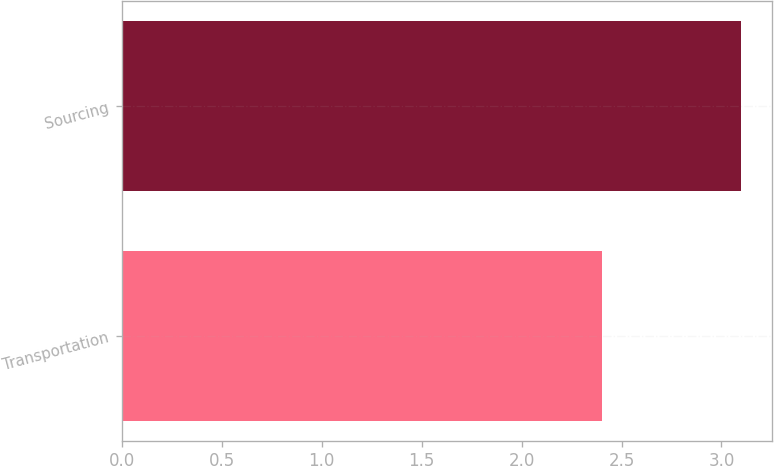Convert chart to OTSL. <chart><loc_0><loc_0><loc_500><loc_500><bar_chart><fcel>Transportation<fcel>Sourcing<nl><fcel>2.4<fcel>3.1<nl></chart> 